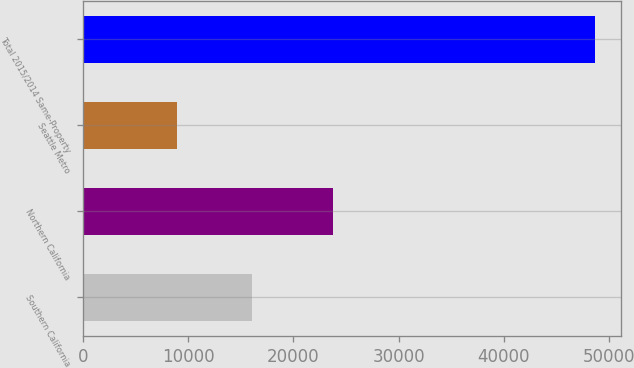<chart> <loc_0><loc_0><loc_500><loc_500><bar_chart><fcel>Southern California<fcel>Northern California<fcel>Seattle Metro<fcel>Total 2015/2014 Same-Property<nl><fcel>16022<fcel>23799<fcel>8924<fcel>48745<nl></chart> 